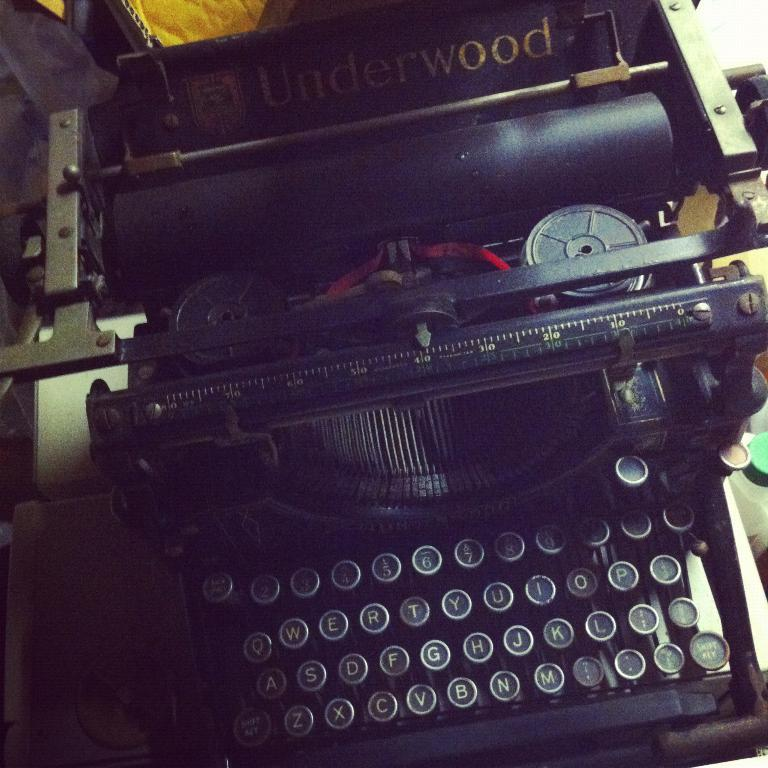<image>
Write a terse but informative summary of the picture. An old type writer and the brand is underwood. 